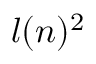<formula> <loc_0><loc_0><loc_500><loc_500>l ( n ) ^ { 2 }</formula> 